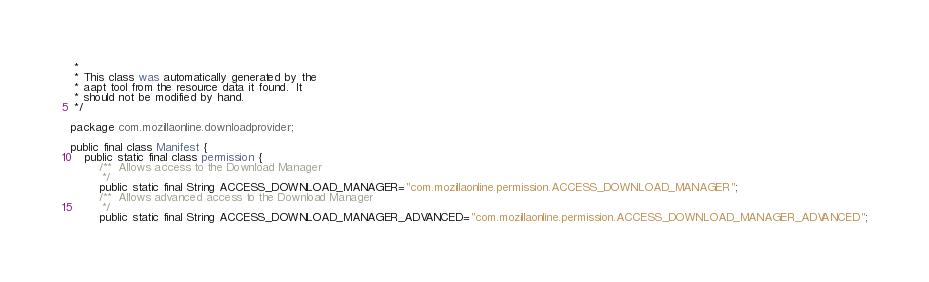<code> <loc_0><loc_0><loc_500><loc_500><_Java_> *
 * This class was automatically generated by the
 * aapt tool from the resource data it found.  It
 * should not be modified by hand.
 */

package com.mozillaonline.downloadprovider;

public final class Manifest {
    public static final class permission {
        /**  Allows access to the Download Manager 
         */
        public static final String ACCESS_DOWNLOAD_MANAGER="com.mozillaonline.permission.ACCESS_DOWNLOAD_MANAGER";
        /**  Allows advanced access to the Download Manager 
         */
        public static final String ACCESS_DOWNLOAD_MANAGER_ADVANCED="com.mozillaonline.permission.ACCESS_DOWNLOAD_MANAGER_ADVANCED";</code> 